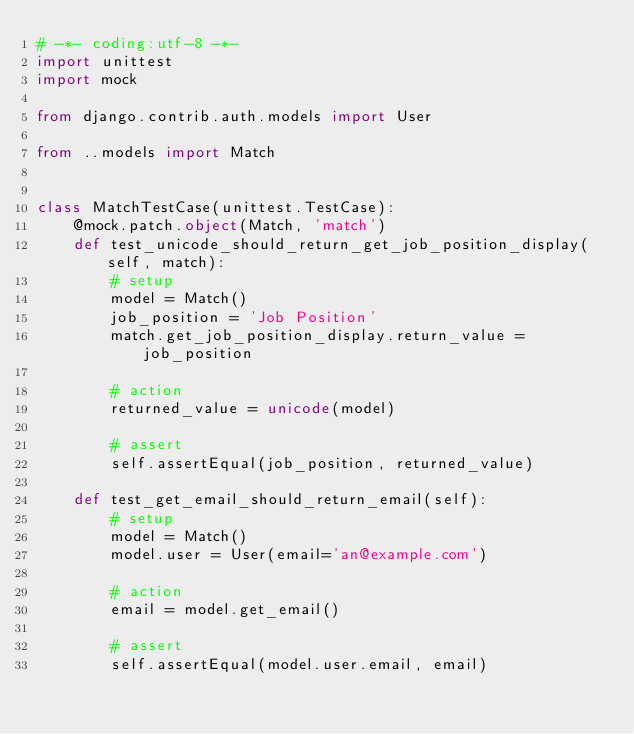Convert code to text. <code><loc_0><loc_0><loc_500><loc_500><_Python_># -*- coding:utf-8 -*-
import unittest
import mock

from django.contrib.auth.models import User

from ..models import Match


class MatchTestCase(unittest.TestCase):
    @mock.patch.object(Match, 'match')
    def test_unicode_should_return_get_job_position_display(self, match):
        # setup
        model = Match()
        job_position = 'Job Position'
        match.get_job_position_display.return_value = job_position

        # action
        returned_value = unicode(model)

        # assert
        self.assertEqual(job_position, returned_value)

    def test_get_email_should_return_email(self):
        # setup
        model = Match()
        model.user = User(email='an@example.com')

        # action
        email = model.get_email()

        # assert
        self.assertEqual(model.user.email, email)
</code> 